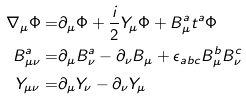<formula> <loc_0><loc_0><loc_500><loc_500>\nabla _ { \mu } \Phi = & \partial _ { \mu } \Phi + \frac { i } { 2 } Y _ { \mu } \Phi + B ^ { a } _ { \mu } t ^ { a } \Phi \\ B ^ { a } _ { \mu \nu } = & \partial _ { \mu } B ^ { a } _ { \nu } - \partial _ { \nu } B _ { \mu } + \epsilon _ { a b c } B ^ { b } _ { \mu } B ^ { c } _ { \nu } \\ Y _ { \mu \nu } = & \partial _ { \mu } Y _ { \nu } - \partial _ { \nu } Y _ { \mu }</formula> 